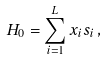Convert formula to latex. <formula><loc_0><loc_0><loc_500><loc_500>H _ { 0 } = \sum _ { i = 1 } ^ { L } x _ { i } s _ { i } \, ,</formula> 